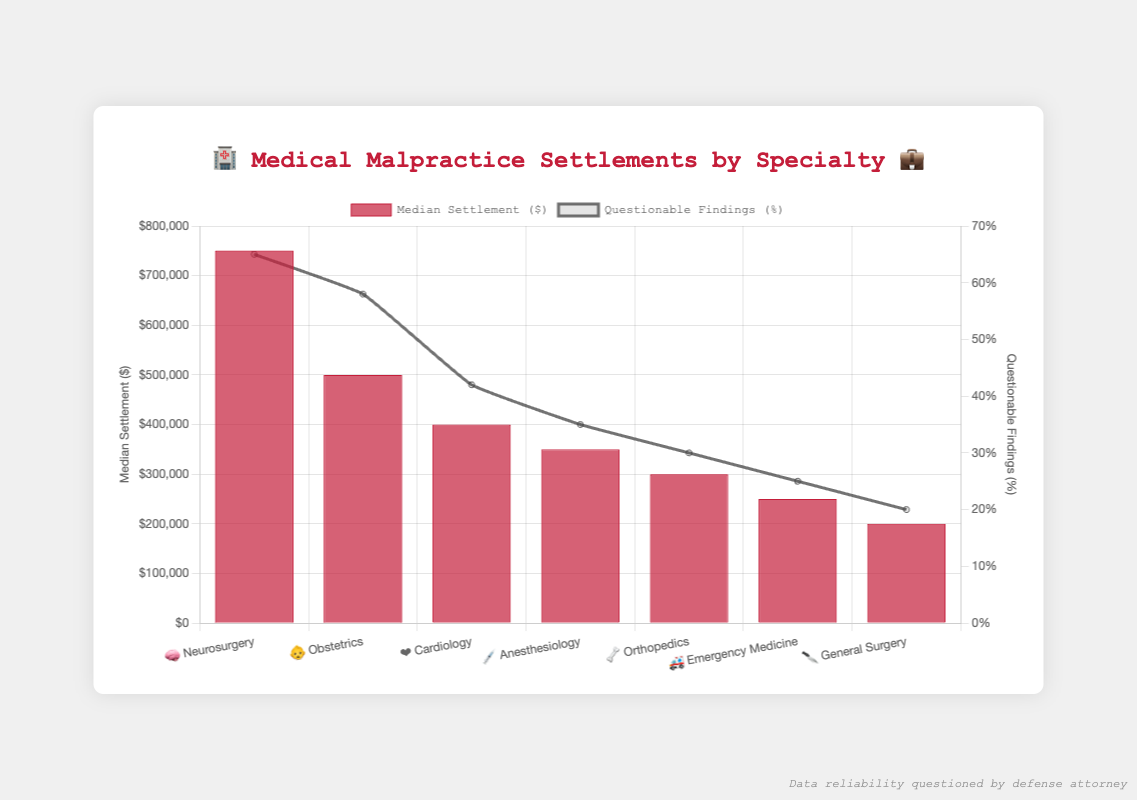What is the title of the chart? The title is located at the top center of the chart and reads "🏥 Medical Malpractice Settlements by Specialty 💼".
Answer: 🏥 Medical Malpractice Settlements by Specialty 💼 Which specialty has the highest median settlement amount? By looking at the bars in the chart, Neurosurgery has the highest median settlement at $750,000.
Answer: Neurosurgery What is the median settlement amount for Orthopedics? Referencing the bar labeled "🦴 Orthopedics" shows that the median settlement amount is $300,000.
Answer: $300,000 How many specialties have a median settlement amount above $400,000? The bars for Neurosurgery, Obstetrics, and Cardiology are above $400,000. Counting these, there are three specialties.
Answer: 3 Which specialty has the lowest percentage of questionable findings? By examining the line chart, General Surgery has the lowest percentage of questionable findings at 20%.
Answer: General Surgery Is the median settlement for Emergency Medicine higher or lower than that for Obstetrics? Compare the bar heights for Emergency Medicine ($250,000) and Obstetrics ($500,000). Emergency Medicine is lower.
Answer: Lower What is the median settlement amount difference between Cardiology and Anesthesiology? Cardiology has $400,000 and Anesthesiology has $350,000. The difference is $400,000 - $350,000 = $50,000.
Answer: $50,000 Which specialty has the second-highest percentage of questionable findings? Looking at the second highest point in the line chart, Obstetrics is second highest at 58%.
Answer: Obstetrics What is the average of the median settlement amounts for Neurosurgery, Obstetrics, and Cardiology combined? Adding the three values: $750,000 + $500,000 + $400,000 = $1,650,000. Divide by 3: $1,650,000 / 3 = $550,000.
Answer: $550,000 Does the trend of median settlement amounts follow a similar trend to the questionable findings? Comparing the bar and line charts, both the highest median settlements and highest questionable findings occur in Neurosurgery and Obstetrics, indicating a similar trend.
Answer: Yes 